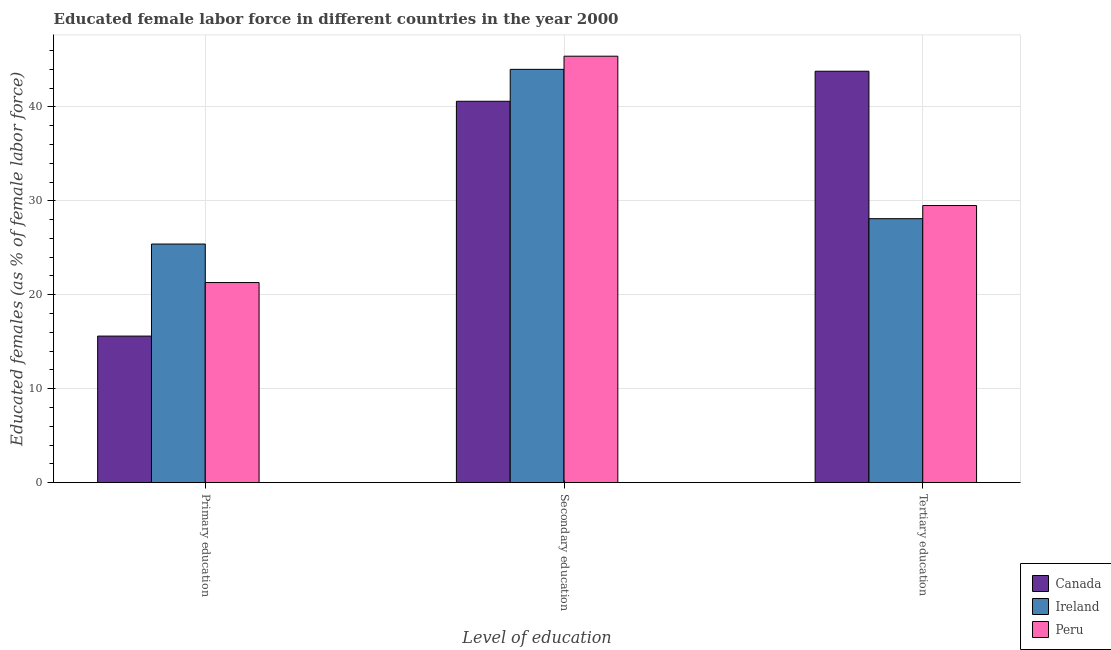Are the number of bars on each tick of the X-axis equal?
Give a very brief answer. Yes. What is the label of the 3rd group of bars from the left?
Your answer should be compact. Tertiary education. What is the percentage of female labor force who received secondary education in Peru?
Ensure brevity in your answer.  45.4. Across all countries, what is the maximum percentage of female labor force who received primary education?
Your answer should be very brief. 25.4. Across all countries, what is the minimum percentage of female labor force who received secondary education?
Make the answer very short. 40.6. In which country was the percentage of female labor force who received secondary education maximum?
Make the answer very short. Peru. In which country was the percentage of female labor force who received tertiary education minimum?
Your answer should be very brief. Ireland. What is the total percentage of female labor force who received secondary education in the graph?
Give a very brief answer. 130. What is the difference between the percentage of female labor force who received tertiary education in Canada and that in Ireland?
Give a very brief answer. 15.7. What is the difference between the percentage of female labor force who received tertiary education in Peru and the percentage of female labor force who received secondary education in Ireland?
Offer a very short reply. -14.5. What is the average percentage of female labor force who received secondary education per country?
Provide a succinct answer. 43.33. What is the difference between the percentage of female labor force who received primary education and percentage of female labor force who received secondary education in Ireland?
Keep it short and to the point. -18.6. In how many countries, is the percentage of female labor force who received primary education greater than 26 %?
Provide a short and direct response. 0. What is the ratio of the percentage of female labor force who received primary education in Ireland to that in Peru?
Your response must be concise. 1.19. What is the difference between the highest and the second highest percentage of female labor force who received primary education?
Give a very brief answer. 4.1. What is the difference between the highest and the lowest percentage of female labor force who received primary education?
Give a very brief answer. 9.8. What does the 1st bar from the left in Secondary education represents?
Provide a short and direct response. Canada. How many bars are there?
Ensure brevity in your answer.  9. How many countries are there in the graph?
Offer a terse response. 3. Are the values on the major ticks of Y-axis written in scientific E-notation?
Your response must be concise. No. Where does the legend appear in the graph?
Provide a short and direct response. Bottom right. How many legend labels are there?
Offer a terse response. 3. How are the legend labels stacked?
Offer a very short reply. Vertical. What is the title of the graph?
Provide a succinct answer. Educated female labor force in different countries in the year 2000. Does "Fiji" appear as one of the legend labels in the graph?
Give a very brief answer. No. What is the label or title of the X-axis?
Offer a very short reply. Level of education. What is the label or title of the Y-axis?
Provide a short and direct response. Educated females (as % of female labor force). What is the Educated females (as % of female labor force) in Canada in Primary education?
Provide a short and direct response. 15.6. What is the Educated females (as % of female labor force) of Ireland in Primary education?
Give a very brief answer. 25.4. What is the Educated females (as % of female labor force) in Peru in Primary education?
Give a very brief answer. 21.3. What is the Educated females (as % of female labor force) of Canada in Secondary education?
Offer a very short reply. 40.6. What is the Educated females (as % of female labor force) in Peru in Secondary education?
Offer a very short reply. 45.4. What is the Educated females (as % of female labor force) of Canada in Tertiary education?
Offer a terse response. 43.8. What is the Educated females (as % of female labor force) of Ireland in Tertiary education?
Make the answer very short. 28.1. What is the Educated females (as % of female labor force) in Peru in Tertiary education?
Offer a very short reply. 29.5. Across all Level of education, what is the maximum Educated females (as % of female labor force) of Canada?
Ensure brevity in your answer.  43.8. Across all Level of education, what is the maximum Educated females (as % of female labor force) in Peru?
Your answer should be compact. 45.4. Across all Level of education, what is the minimum Educated females (as % of female labor force) of Canada?
Offer a terse response. 15.6. Across all Level of education, what is the minimum Educated females (as % of female labor force) of Ireland?
Your answer should be very brief. 25.4. Across all Level of education, what is the minimum Educated females (as % of female labor force) of Peru?
Ensure brevity in your answer.  21.3. What is the total Educated females (as % of female labor force) in Ireland in the graph?
Your answer should be compact. 97.5. What is the total Educated females (as % of female labor force) in Peru in the graph?
Offer a terse response. 96.2. What is the difference between the Educated females (as % of female labor force) in Ireland in Primary education and that in Secondary education?
Provide a succinct answer. -18.6. What is the difference between the Educated females (as % of female labor force) in Peru in Primary education and that in Secondary education?
Ensure brevity in your answer.  -24.1. What is the difference between the Educated females (as % of female labor force) of Canada in Primary education and that in Tertiary education?
Your answer should be very brief. -28.2. What is the difference between the Educated females (as % of female labor force) in Canada in Secondary education and that in Tertiary education?
Provide a succinct answer. -3.2. What is the difference between the Educated females (as % of female labor force) in Peru in Secondary education and that in Tertiary education?
Make the answer very short. 15.9. What is the difference between the Educated females (as % of female labor force) of Canada in Primary education and the Educated females (as % of female labor force) of Ireland in Secondary education?
Make the answer very short. -28.4. What is the difference between the Educated females (as % of female labor force) in Canada in Primary education and the Educated females (as % of female labor force) in Peru in Secondary education?
Offer a terse response. -29.8. What is the difference between the Educated females (as % of female labor force) in Ireland in Primary education and the Educated females (as % of female labor force) in Peru in Secondary education?
Ensure brevity in your answer.  -20. What is the difference between the Educated females (as % of female labor force) in Canada in Secondary education and the Educated females (as % of female labor force) in Peru in Tertiary education?
Ensure brevity in your answer.  11.1. What is the difference between the Educated females (as % of female labor force) of Ireland in Secondary education and the Educated females (as % of female labor force) of Peru in Tertiary education?
Your response must be concise. 14.5. What is the average Educated females (as % of female labor force) of Canada per Level of education?
Your answer should be compact. 33.33. What is the average Educated females (as % of female labor force) in Ireland per Level of education?
Make the answer very short. 32.5. What is the average Educated females (as % of female labor force) in Peru per Level of education?
Offer a terse response. 32.07. What is the difference between the Educated females (as % of female labor force) in Canada and Educated females (as % of female labor force) in Peru in Primary education?
Give a very brief answer. -5.7. What is the difference between the Educated females (as % of female labor force) of Ireland and Educated females (as % of female labor force) of Peru in Primary education?
Your answer should be very brief. 4.1. What is the difference between the Educated females (as % of female labor force) in Canada and Educated females (as % of female labor force) in Peru in Secondary education?
Give a very brief answer. -4.8. What is the difference between the Educated females (as % of female labor force) in Ireland and Educated females (as % of female labor force) in Peru in Secondary education?
Your answer should be very brief. -1.4. What is the difference between the Educated females (as % of female labor force) in Canada and Educated females (as % of female labor force) in Peru in Tertiary education?
Your answer should be compact. 14.3. What is the ratio of the Educated females (as % of female labor force) of Canada in Primary education to that in Secondary education?
Make the answer very short. 0.38. What is the ratio of the Educated females (as % of female labor force) in Ireland in Primary education to that in Secondary education?
Ensure brevity in your answer.  0.58. What is the ratio of the Educated females (as % of female labor force) of Peru in Primary education to that in Secondary education?
Provide a succinct answer. 0.47. What is the ratio of the Educated females (as % of female labor force) of Canada in Primary education to that in Tertiary education?
Offer a very short reply. 0.36. What is the ratio of the Educated females (as % of female labor force) in Ireland in Primary education to that in Tertiary education?
Your answer should be compact. 0.9. What is the ratio of the Educated females (as % of female labor force) in Peru in Primary education to that in Tertiary education?
Your response must be concise. 0.72. What is the ratio of the Educated females (as % of female labor force) in Canada in Secondary education to that in Tertiary education?
Your answer should be compact. 0.93. What is the ratio of the Educated females (as % of female labor force) of Ireland in Secondary education to that in Tertiary education?
Your answer should be compact. 1.57. What is the ratio of the Educated females (as % of female labor force) in Peru in Secondary education to that in Tertiary education?
Offer a very short reply. 1.54. What is the difference between the highest and the second highest Educated females (as % of female labor force) of Canada?
Your answer should be compact. 3.2. What is the difference between the highest and the second highest Educated females (as % of female labor force) of Peru?
Provide a succinct answer. 15.9. What is the difference between the highest and the lowest Educated females (as % of female labor force) of Canada?
Provide a succinct answer. 28.2. What is the difference between the highest and the lowest Educated females (as % of female labor force) of Ireland?
Make the answer very short. 18.6. What is the difference between the highest and the lowest Educated females (as % of female labor force) in Peru?
Your response must be concise. 24.1. 